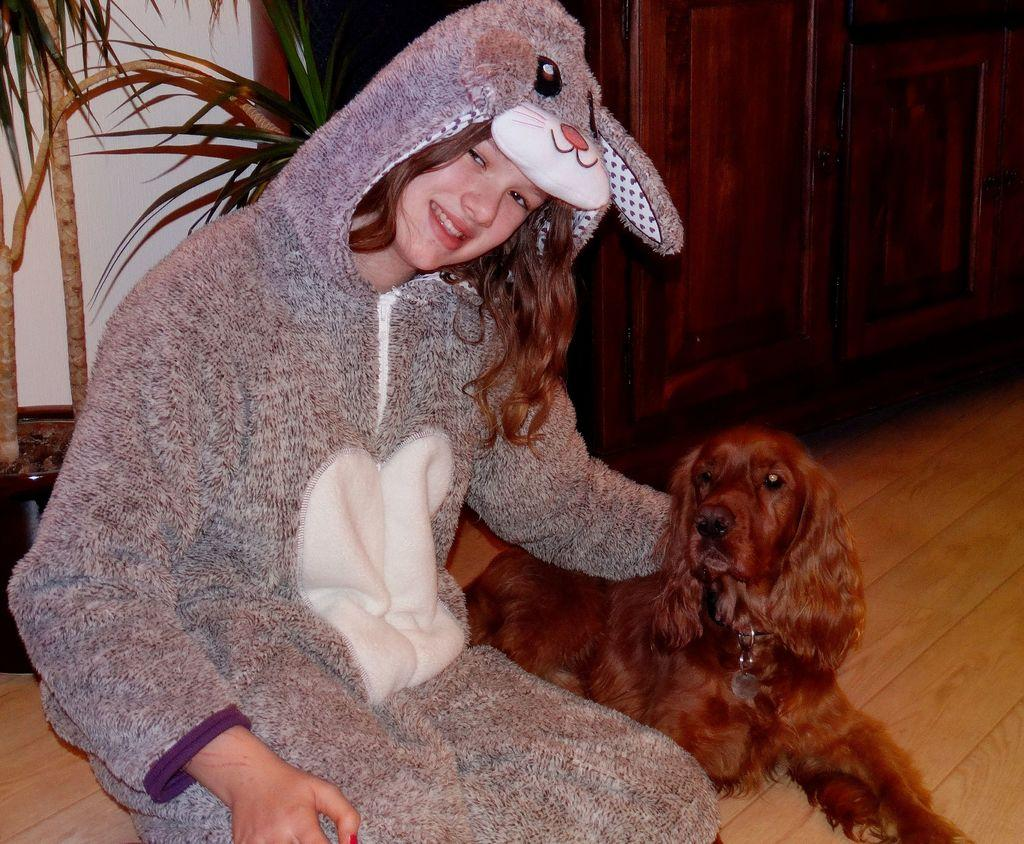Who is the main subject in the image? There is a girl in the image. What is the girl wearing? The girl is wearing a costume. Is there any other living creature in the image? Yes, there is a dog beside the girl. What can be seen in the background of the image? There is a plant visible behind the girl. What type of screw can be seen holding the costume together in the image? There is no screw visible in the image, and the costume is not held together by any screws. 